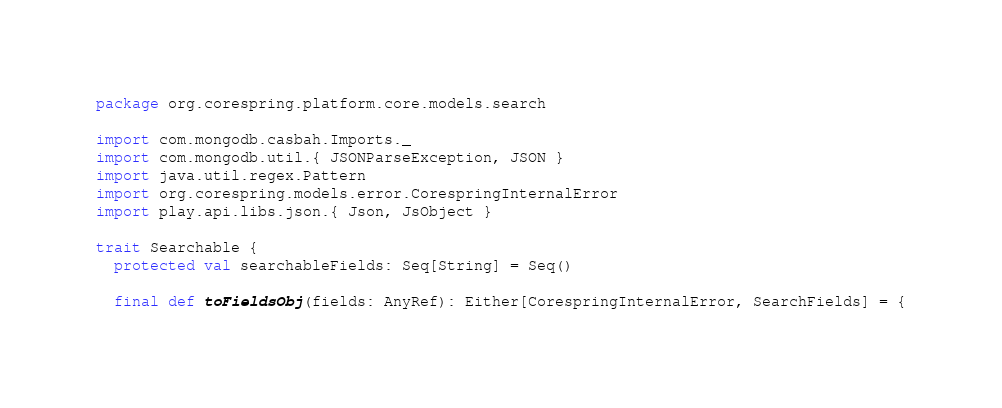<code> <loc_0><loc_0><loc_500><loc_500><_Scala_>package org.corespring.platform.core.models.search

import com.mongodb.casbah.Imports._
import com.mongodb.util.{ JSONParseException, JSON }
import java.util.regex.Pattern
import org.corespring.models.error.CorespringInternalError
import play.api.libs.json.{ Json, JsObject }

trait Searchable {
  protected val searchableFields: Seq[String] = Seq()

  final def toFieldsObj(fields: AnyRef): Either[CorespringInternalError, SearchFields] = {</code> 